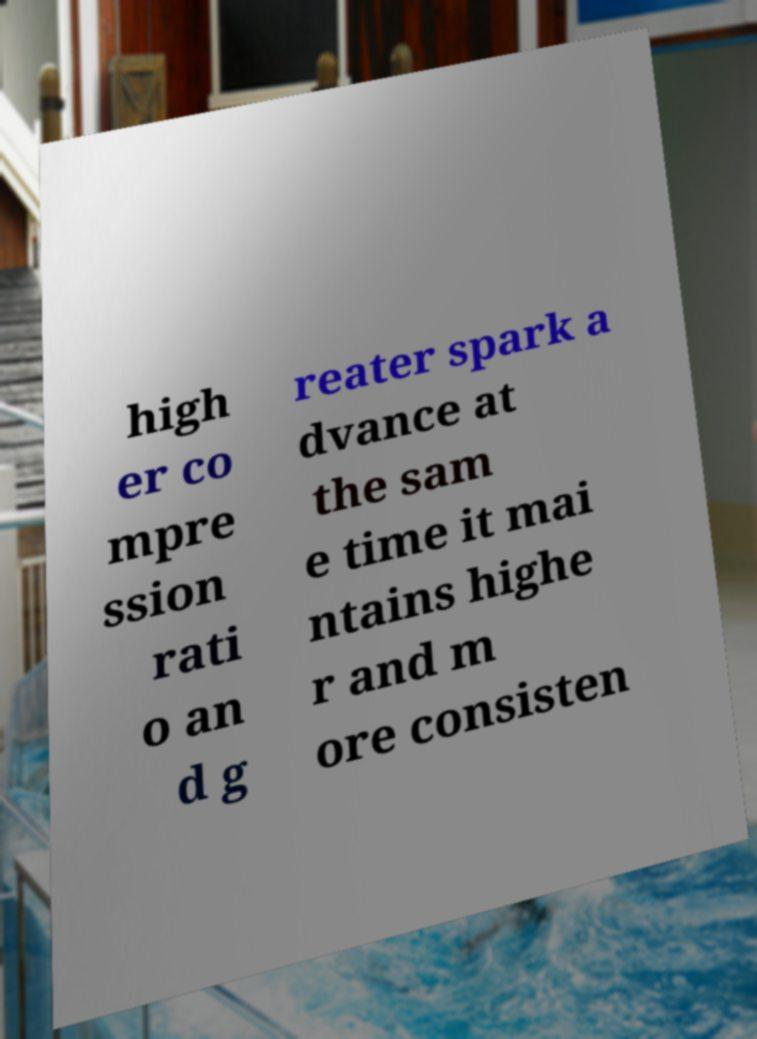Please identify and transcribe the text found in this image. high er co mpre ssion rati o an d g reater spark a dvance at the sam e time it mai ntains highe r and m ore consisten 